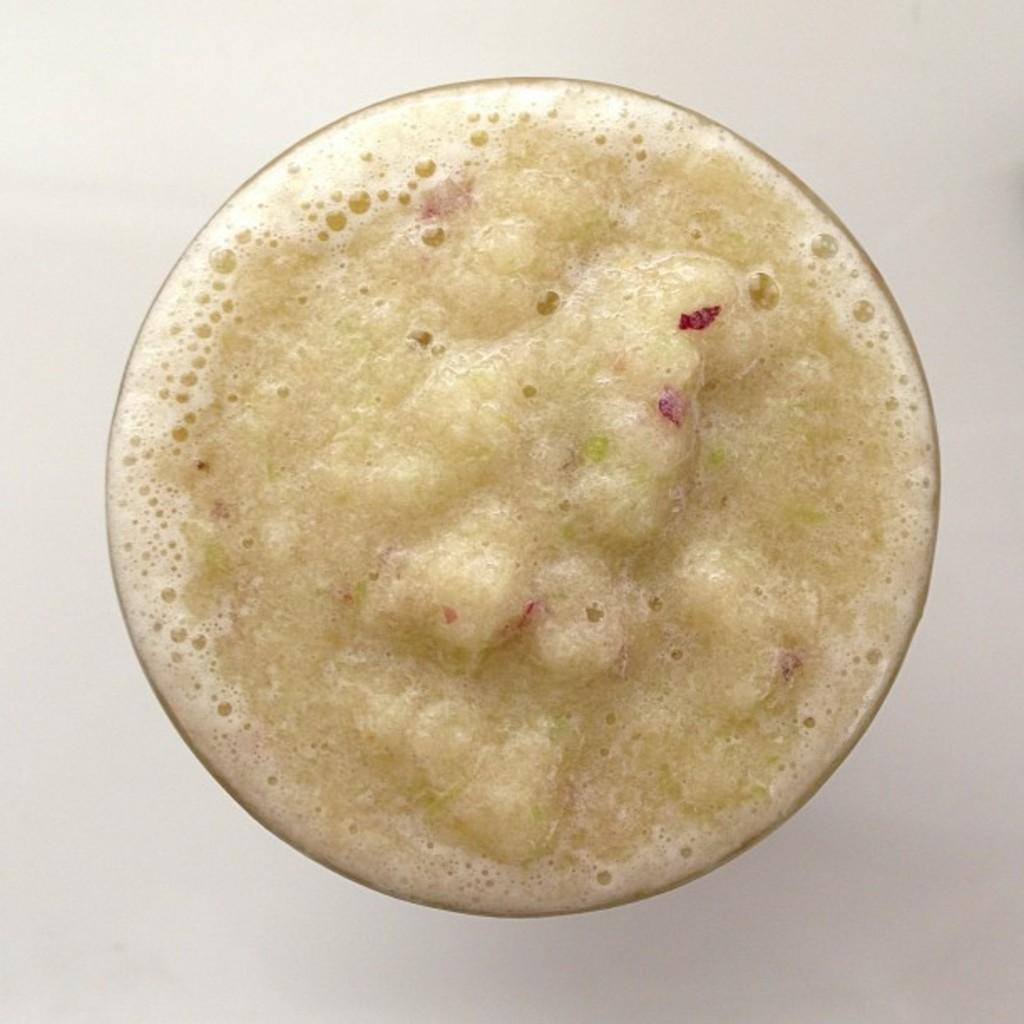What is the main subject in the image? There is a drink in the image. What can be observed about the background of the image? The background of the image is white in color. How does the acoustics of the room affect the sound of the drink being poured in the image? There is no information about the acoustics of the room or the sound of the drink being poured in the image. 